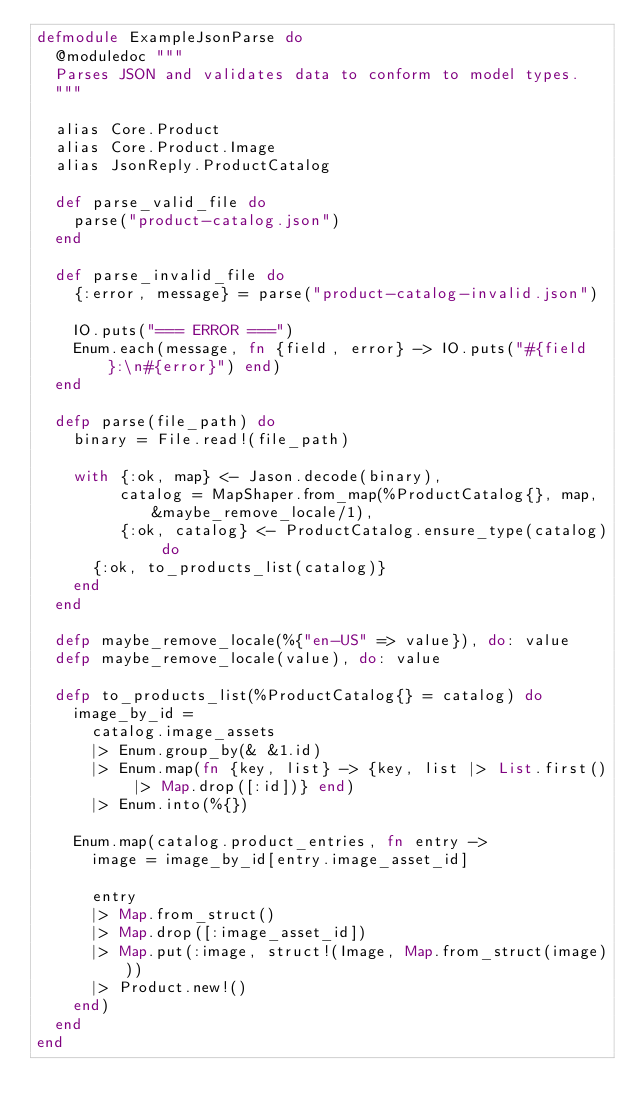<code> <loc_0><loc_0><loc_500><loc_500><_Elixir_>defmodule ExampleJsonParse do
  @moduledoc """
  Parses JSON and validates data to conform to model types.
  """

  alias Core.Product
  alias Core.Product.Image
  alias JsonReply.ProductCatalog

  def parse_valid_file do
    parse("product-catalog.json")
  end

  def parse_invalid_file do
    {:error, message} = parse("product-catalog-invalid.json")

    IO.puts("=== ERROR ===")
    Enum.each(message, fn {field, error} -> IO.puts("#{field}:\n#{error}") end)
  end

  defp parse(file_path) do
    binary = File.read!(file_path)

    with {:ok, map} <- Jason.decode(binary),
         catalog = MapShaper.from_map(%ProductCatalog{}, map, &maybe_remove_locale/1),
         {:ok, catalog} <- ProductCatalog.ensure_type(catalog) do
      {:ok, to_products_list(catalog)}
    end
  end

  defp maybe_remove_locale(%{"en-US" => value}), do: value
  defp maybe_remove_locale(value), do: value

  defp to_products_list(%ProductCatalog{} = catalog) do
    image_by_id =
      catalog.image_assets
      |> Enum.group_by(& &1.id)
      |> Enum.map(fn {key, list} -> {key, list |> List.first() |> Map.drop([:id])} end)
      |> Enum.into(%{})

    Enum.map(catalog.product_entries, fn entry ->
      image = image_by_id[entry.image_asset_id]

      entry
      |> Map.from_struct()
      |> Map.drop([:image_asset_id])
      |> Map.put(:image, struct!(Image, Map.from_struct(image)))
      |> Product.new!()
    end)
  end
end
</code> 